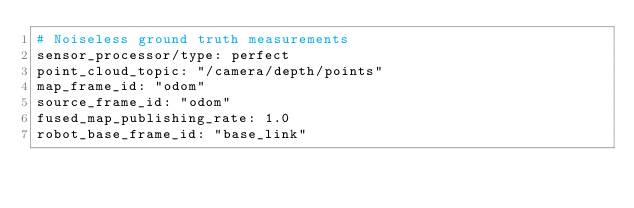<code> <loc_0><loc_0><loc_500><loc_500><_YAML_># Noiseless ground truth measurements
sensor_processor/type: perfect
point_cloud_topic: "/camera/depth/points"
map_frame_id: "odom"
source_frame_id: "odom"
fused_map_publishing_rate: 1.0
robot_base_frame_id: "base_link"</code> 